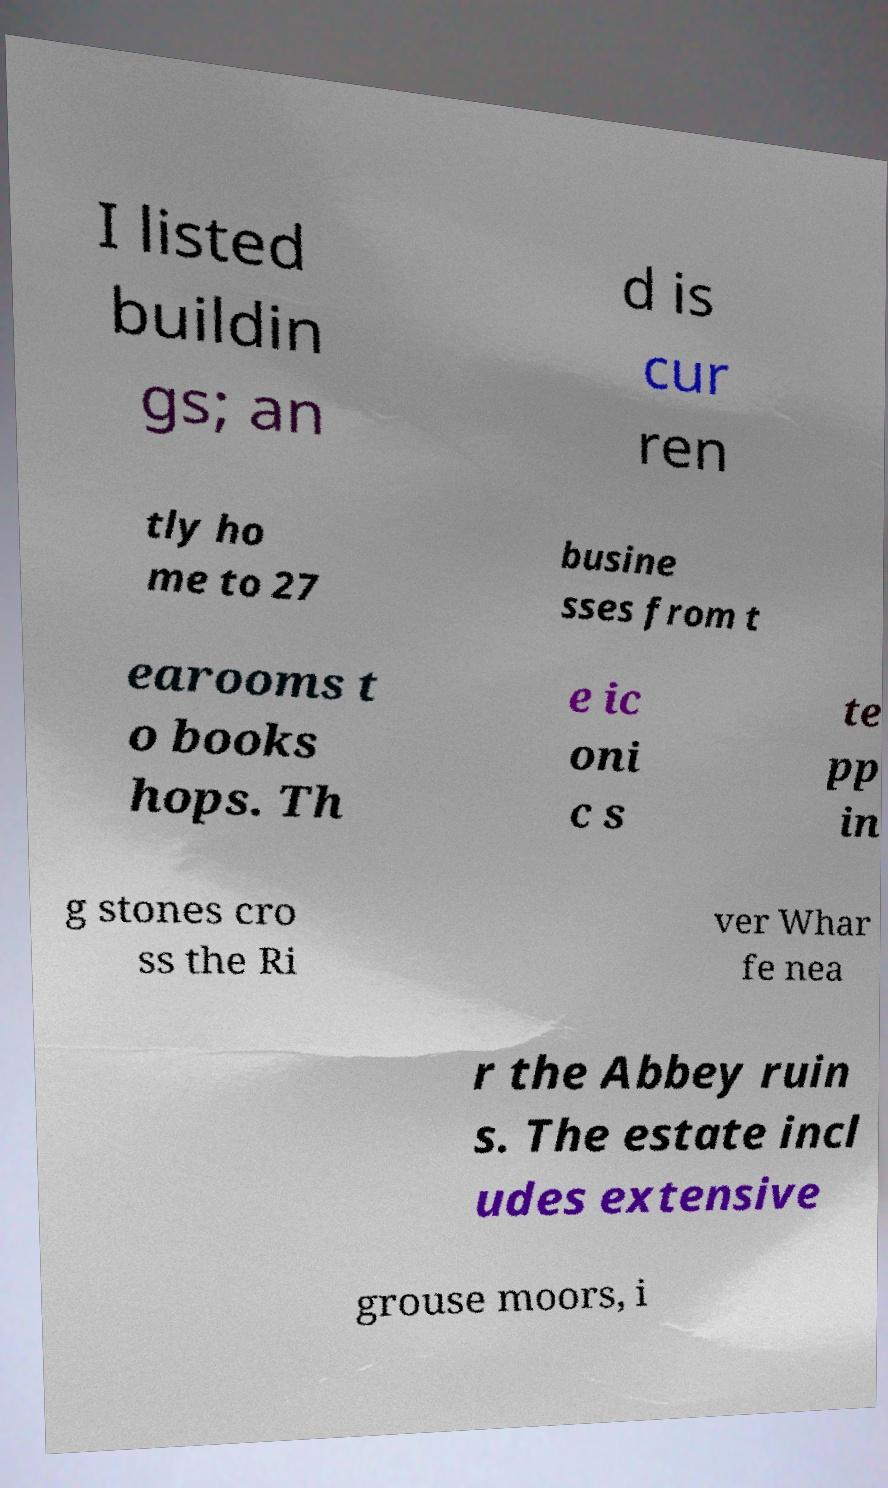Can you read and provide the text displayed in the image?This photo seems to have some interesting text. Can you extract and type it out for me? I listed buildin gs; an d is cur ren tly ho me to 27 busine sses from t earooms t o books hops. Th e ic oni c s te pp in g stones cro ss the Ri ver Whar fe nea r the Abbey ruin s. The estate incl udes extensive grouse moors, i 